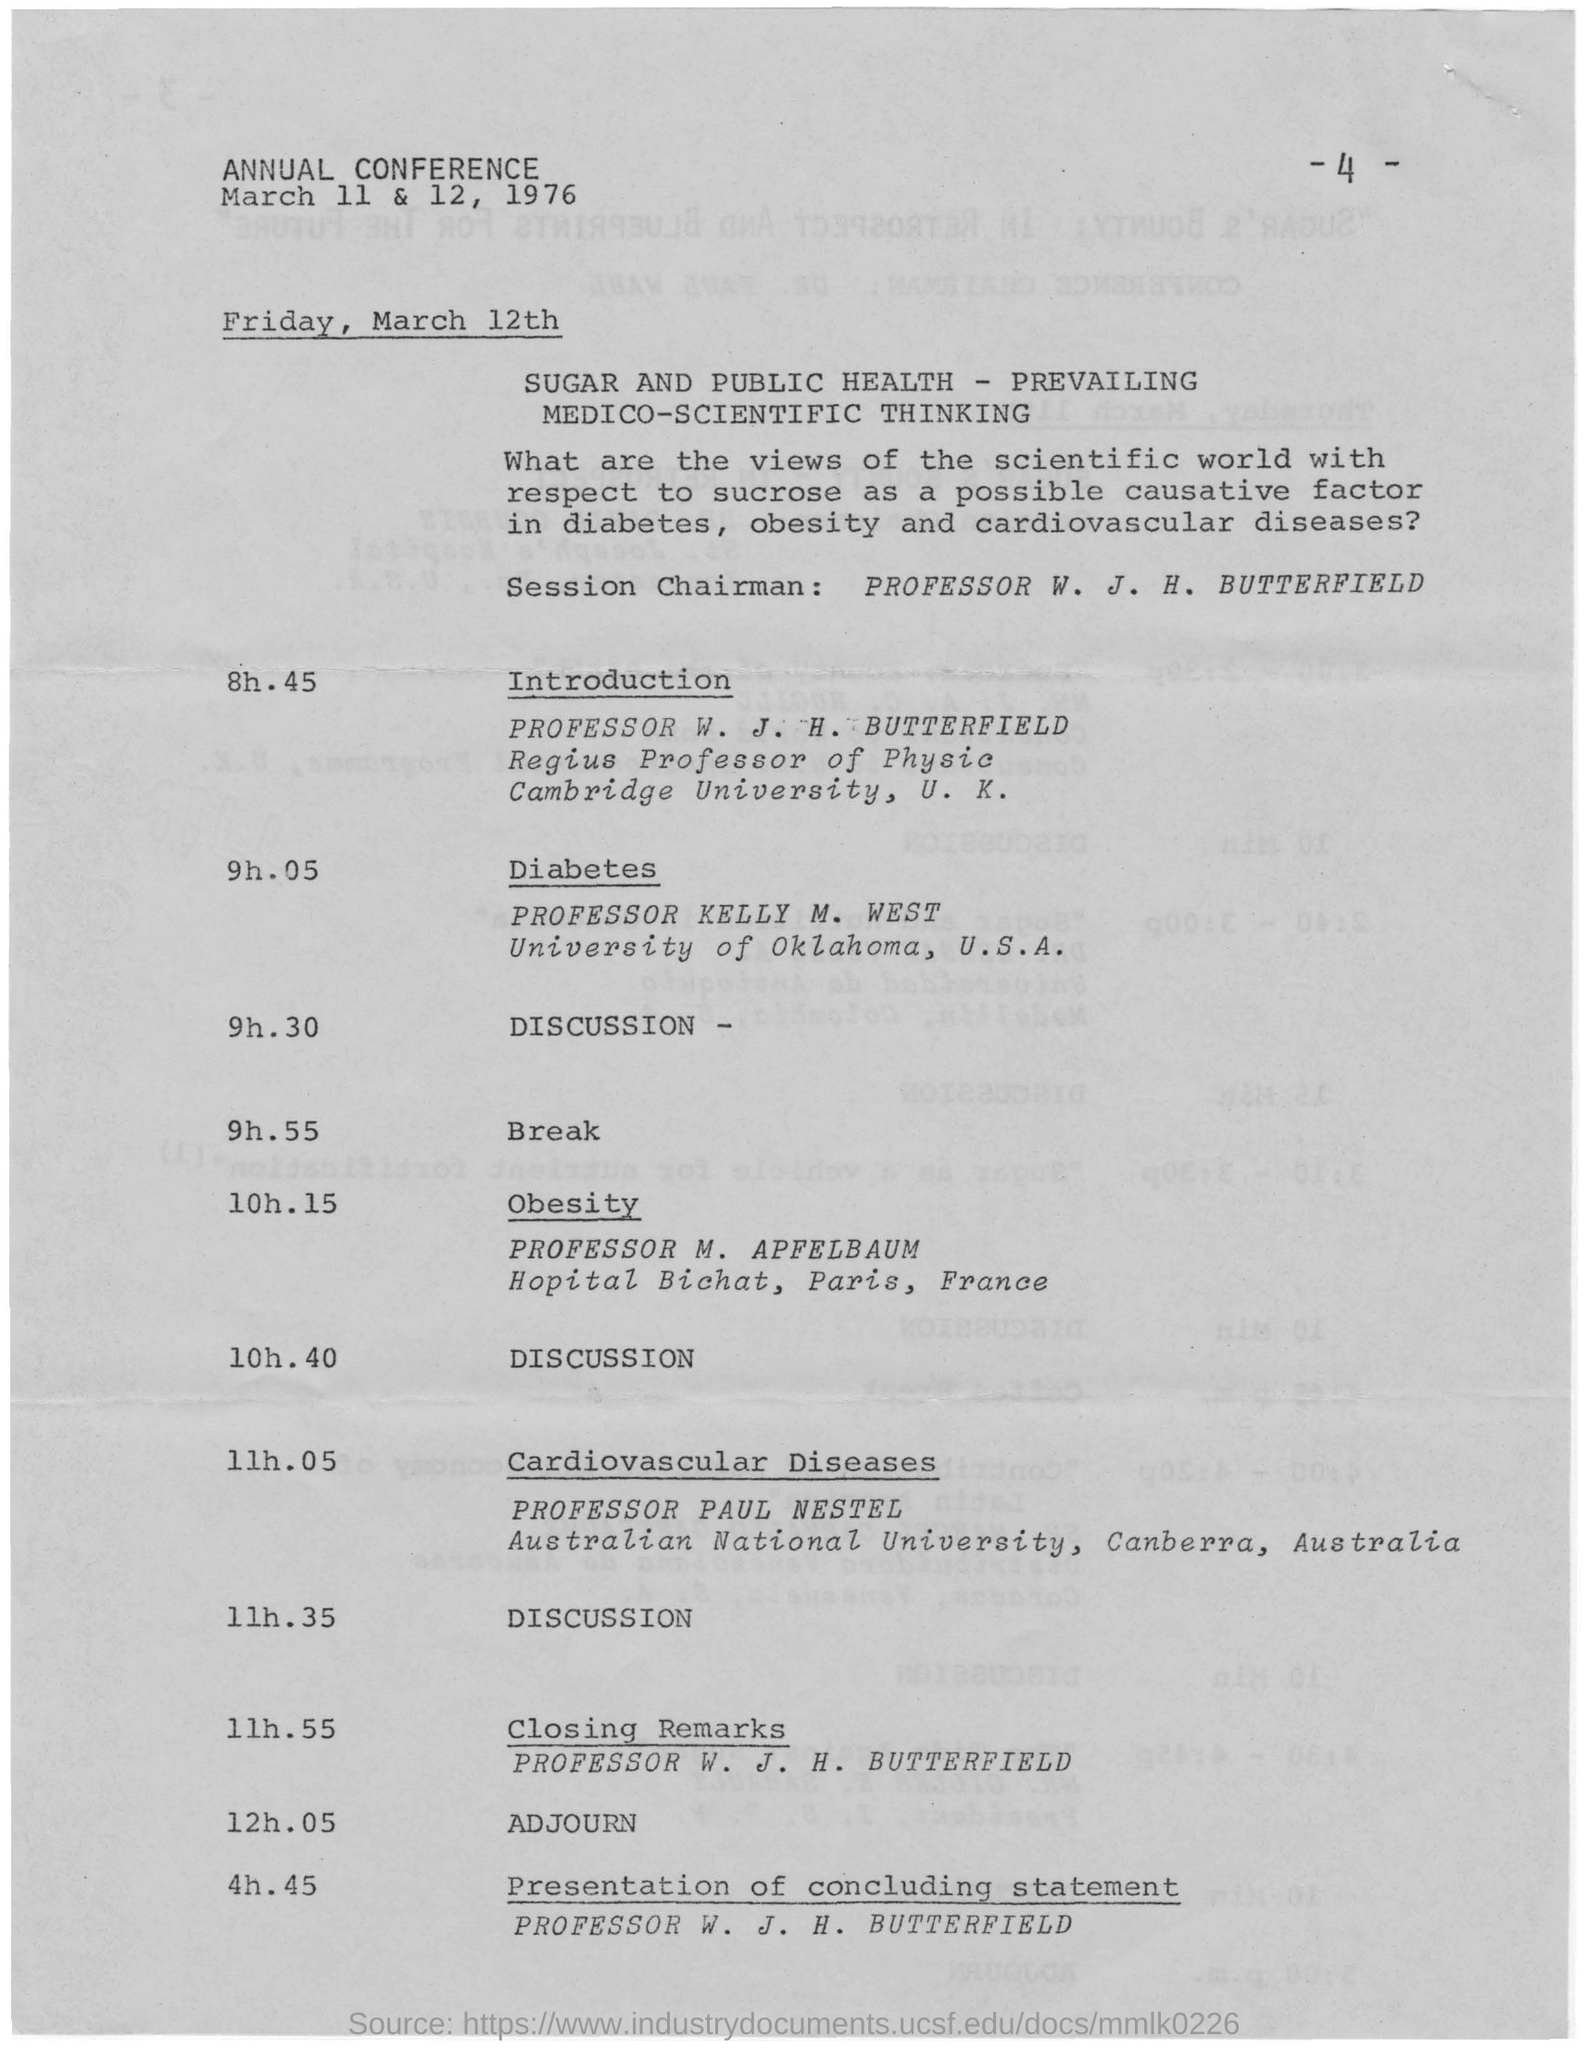What is the page no mentioned in this document?
Offer a terse response. - 4 -. What is the last name on this document?
Your answer should be very brief. PROFESSOR W. J. H. BUTTERFIELD. Who is the Session Chairman?
Make the answer very short. PROFESSOR W. J. H. BUTTERFIELD. 